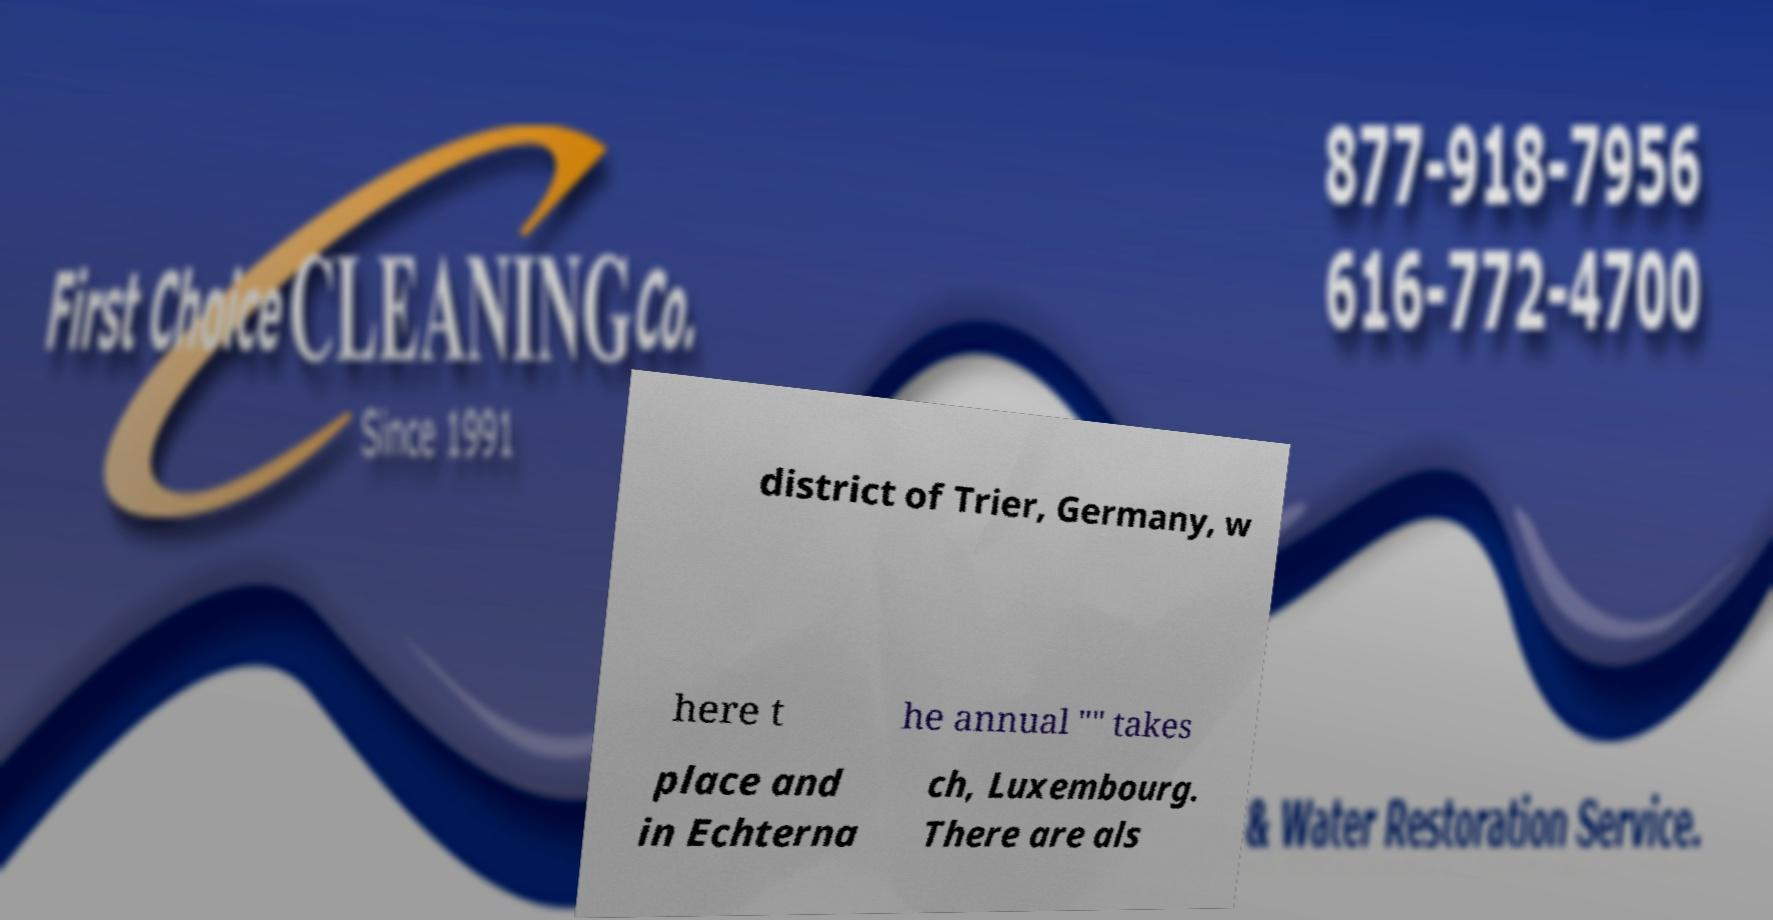There's text embedded in this image that I need extracted. Can you transcribe it verbatim? district of Trier, Germany, w here t he annual "" takes place and in Echterna ch, Luxembourg. There are als 